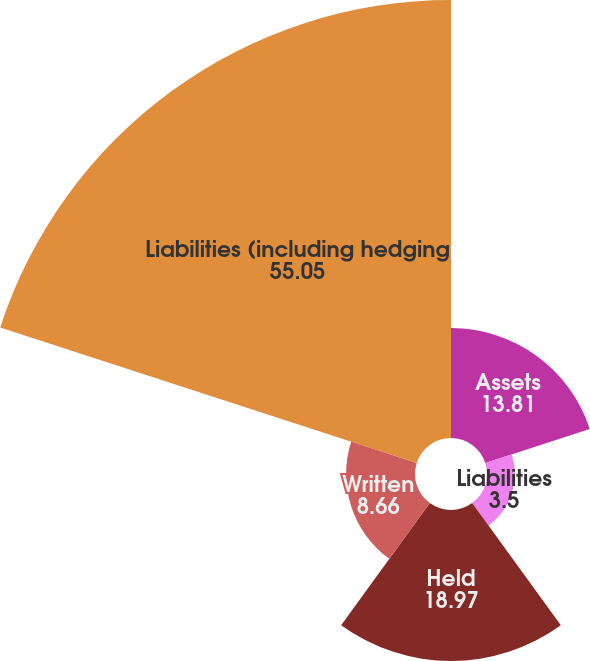Convert chart to OTSL. <chart><loc_0><loc_0><loc_500><loc_500><pie_chart><fcel>Assets<fcel>Liabilities<fcel>Held<fcel>Written<fcel>Liabilities (including hedging<nl><fcel>13.81%<fcel>3.5%<fcel>18.97%<fcel>8.66%<fcel>55.05%<nl></chart> 